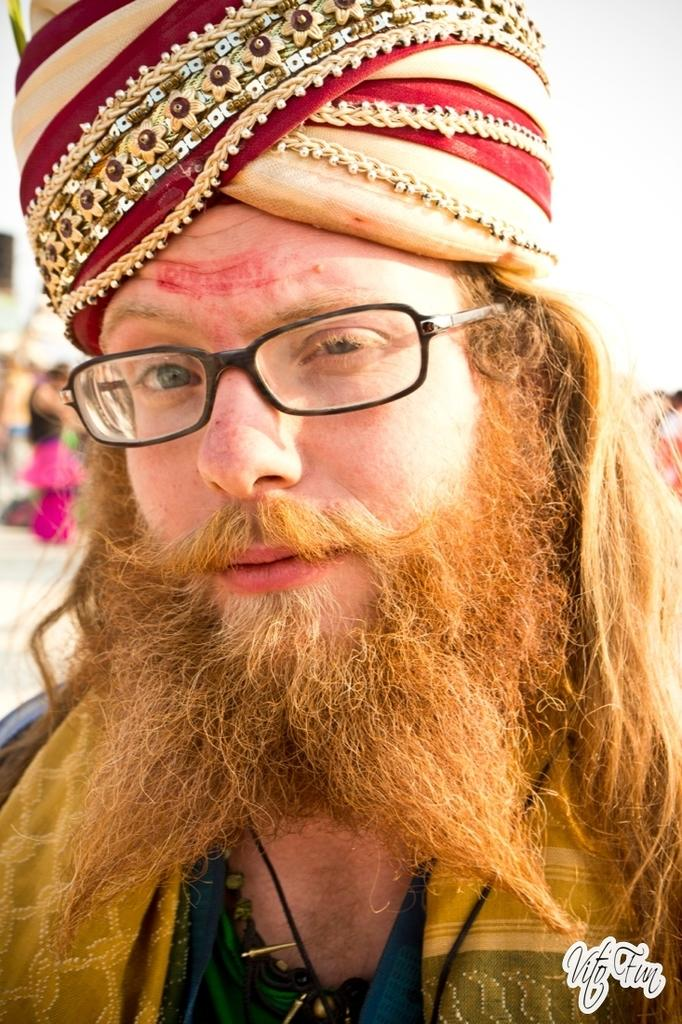What is the main subject of the image? The main subject of the image is a man. Can you describe the man's appearance? The man is wearing clothes, spectacles, and a men's bridal cap. What can be said about the background of the image? The background of the image is blurred. Is there any additional information visible in the image? Yes, there is a watermark in the bottom right corner of the image. What type of agreement can be seen in the aftermath of the picture? There is no agreement or aftermath depicted in the image; it features a man wearing spectacles, a men's bridal cap, and clothes, with a blurred background and a watermark in the bottom right corner. 